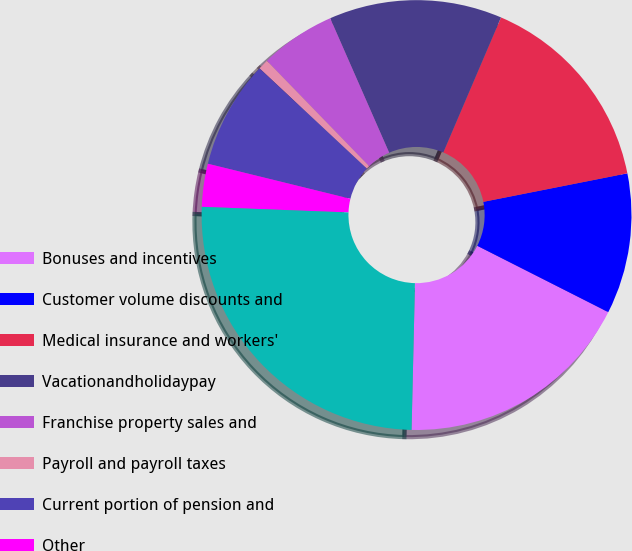<chart> <loc_0><loc_0><loc_500><loc_500><pie_chart><fcel>Bonuses and incentives<fcel>Customer volume discounts and<fcel>Medical insurance and workers'<fcel>Vacationandholidaypay<fcel>Franchise property sales and<fcel>Payroll and payroll taxes<fcel>Current portion of pension and<fcel>Other<fcel>Total<nl><fcel>17.91%<fcel>10.57%<fcel>15.46%<fcel>13.01%<fcel>5.68%<fcel>0.78%<fcel>8.12%<fcel>3.23%<fcel>25.24%<nl></chart> 